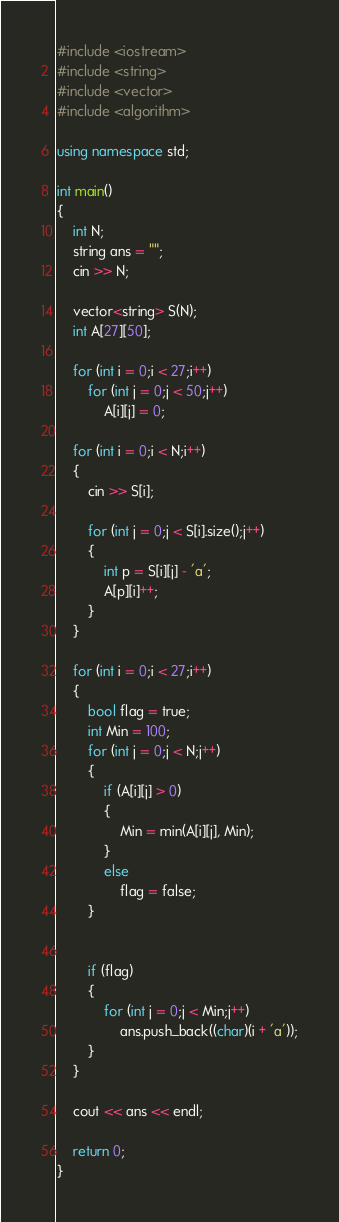<code> <loc_0><loc_0><loc_500><loc_500><_C++_>#include <iostream>
#include <string>
#include <vector>
#include <algorithm>

using namespace std;

int main()
{
	int N;
	string ans = "";
	cin >> N;

	vector<string> S(N);
	int A[27][50];

	for (int i = 0;i < 27;i++)
		for (int j = 0;j < 50;j++)
			A[i][j] = 0;

	for (int i = 0;i < N;i++)
	{
		cin >> S[i];

		for (int j = 0;j < S[i].size();j++)
		{
			int p = S[i][j] - 'a';
			A[p][i]++;
		}
	}

	for (int i = 0;i < 27;i++)
	{
		bool flag = true;
		int Min = 100;
		for (int j = 0;j < N;j++)
		{
			if (A[i][j] > 0)
			{
				Min = min(A[i][j], Min);
			}
			else
				flag = false;
		}


		if (flag)
		{
			for (int j = 0;j < Min;j++)
				ans.push_back((char)(i + 'a'));
		}
	}

	cout << ans << endl;

	return 0;
}
</code> 